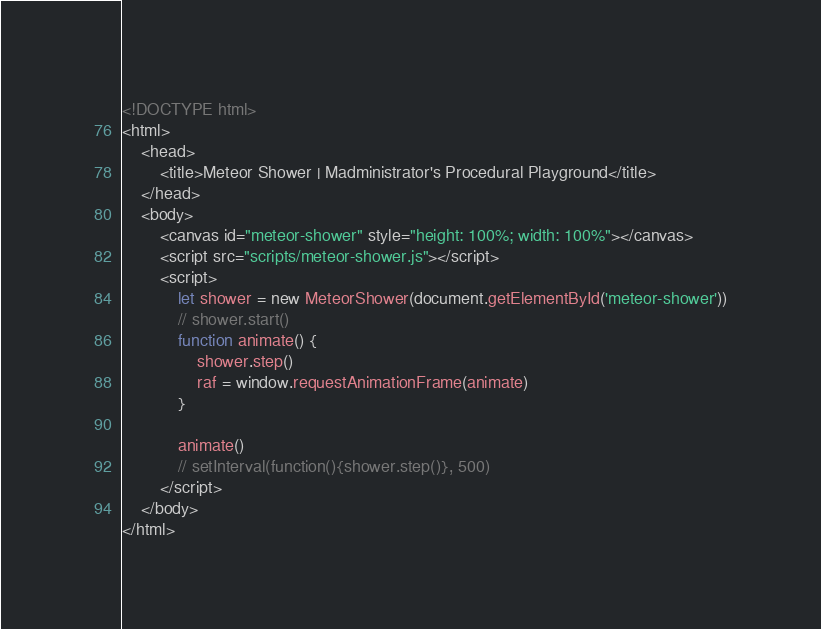<code> <loc_0><loc_0><loc_500><loc_500><_HTML_><!DOCTYPE html>
<html>
    <head>
        <title>Meteor Shower | Madministrator's Procedural Playground</title>
    </head>
    <body>
        <canvas id="meteor-shower" style="height: 100%; width: 100%"></canvas>
        <script src="scripts/meteor-shower.js"></script>
        <script>
            let shower = new MeteorShower(document.getElementById('meteor-shower'))
            // shower.start()
            function animate() {
                shower.step()
                raf = window.requestAnimationFrame(animate)
            }

            animate()
            // setInterval(function(){shower.step()}, 500)
        </script>
    </body>
</html></code> 